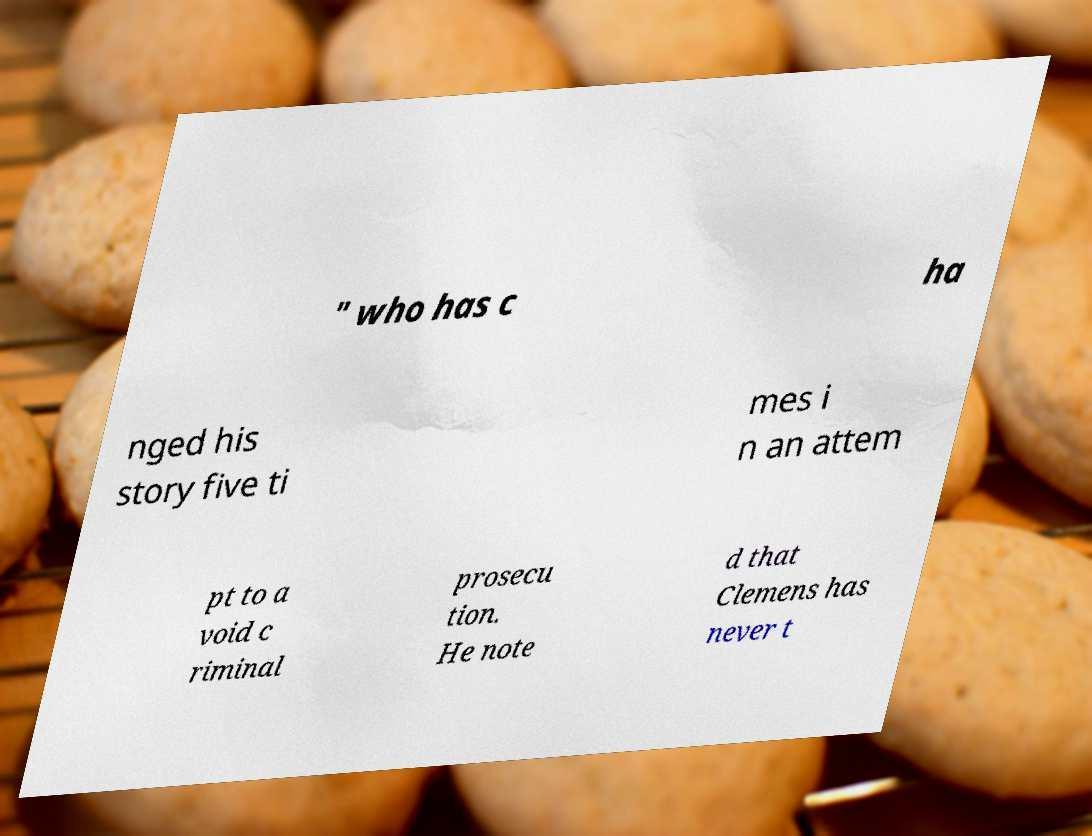There's text embedded in this image that I need extracted. Can you transcribe it verbatim? " who has c ha nged his story five ti mes i n an attem pt to a void c riminal prosecu tion. He note d that Clemens has never t 